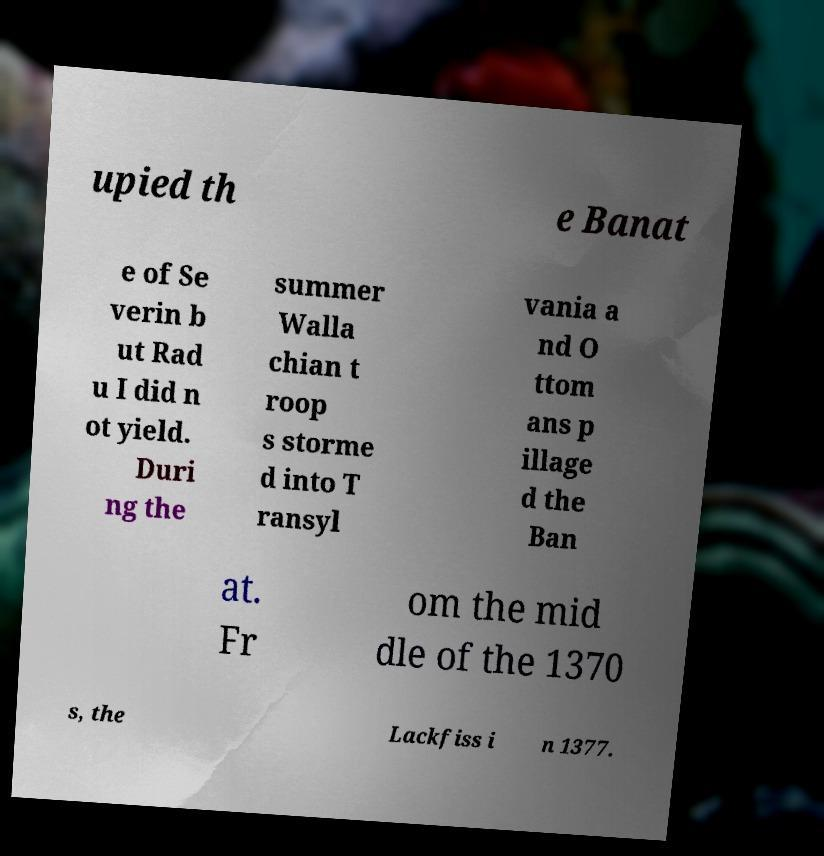Can you read and provide the text displayed in the image?This photo seems to have some interesting text. Can you extract and type it out for me? upied th e Banat e of Se verin b ut Rad u I did n ot yield. Duri ng the summer Walla chian t roop s storme d into T ransyl vania a nd O ttom ans p illage d the Ban at. Fr om the mid dle of the 1370 s, the Lackfiss i n 1377. 